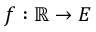<formula> <loc_0><loc_0><loc_500><loc_500>f \colon \mathbb { R } \to E</formula> 